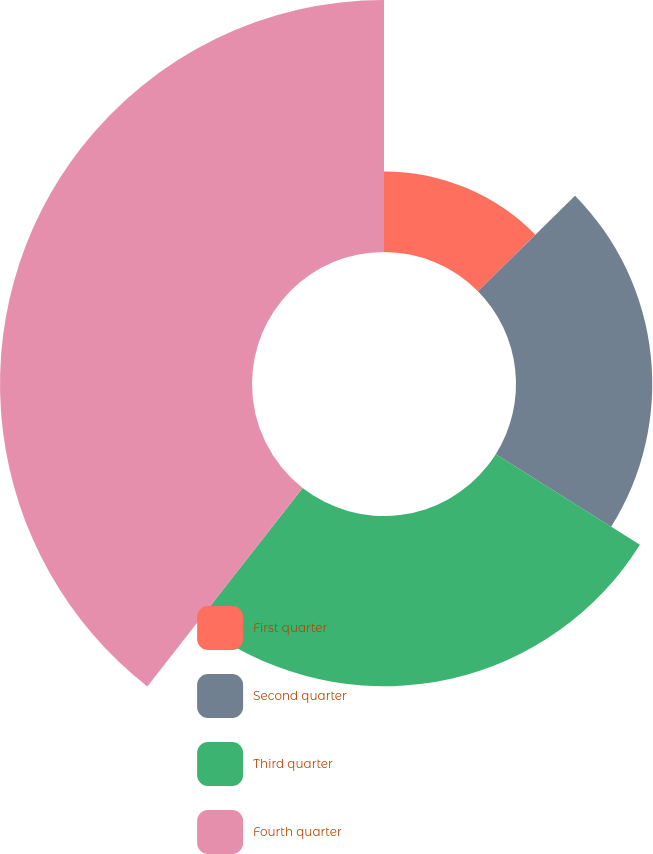<chart> <loc_0><loc_0><loc_500><loc_500><pie_chart><fcel>First quarter<fcel>Second quarter<fcel>Third quarter<fcel>Fourth quarter<nl><fcel>12.61%<fcel>21.32%<fcel>26.64%<fcel>39.43%<nl></chart> 